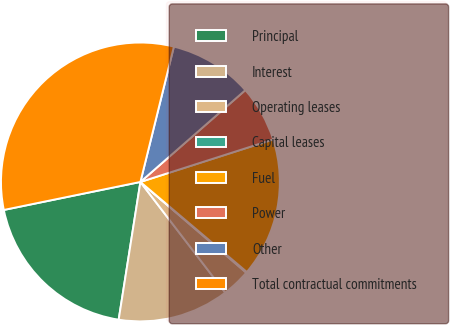Convert chart. <chart><loc_0><loc_0><loc_500><loc_500><pie_chart><fcel>Principal<fcel>Interest<fcel>Operating leases<fcel>Capital leases<fcel>Fuel<fcel>Power<fcel>Other<fcel>Total contractual commitments<nl><fcel>19.29%<fcel>12.9%<fcel>3.31%<fcel>0.11%<fcel>16.1%<fcel>6.51%<fcel>9.7%<fcel>32.08%<nl></chart> 